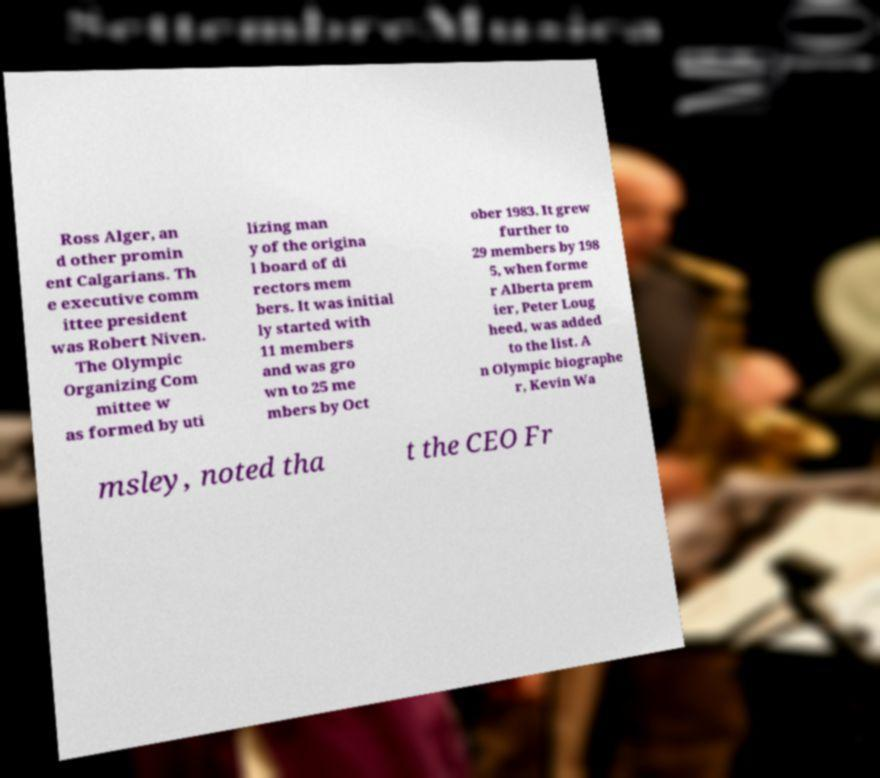Can you read and provide the text displayed in the image?This photo seems to have some interesting text. Can you extract and type it out for me? Ross Alger, an d other promin ent Calgarians. Th e executive comm ittee president was Robert Niven. The Olympic Organizing Com mittee w as formed by uti lizing man y of the origina l board of di rectors mem bers. It was initial ly started with 11 members and was gro wn to 25 me mbers by Oct ober 1983. It grew further to 29 members by 198 5, when forme r Alberta prem ier, Peter Loug heed, was added to the list. A n Olympic biographe r, Kevin Wa msley, noted tha t the CEO Fr 